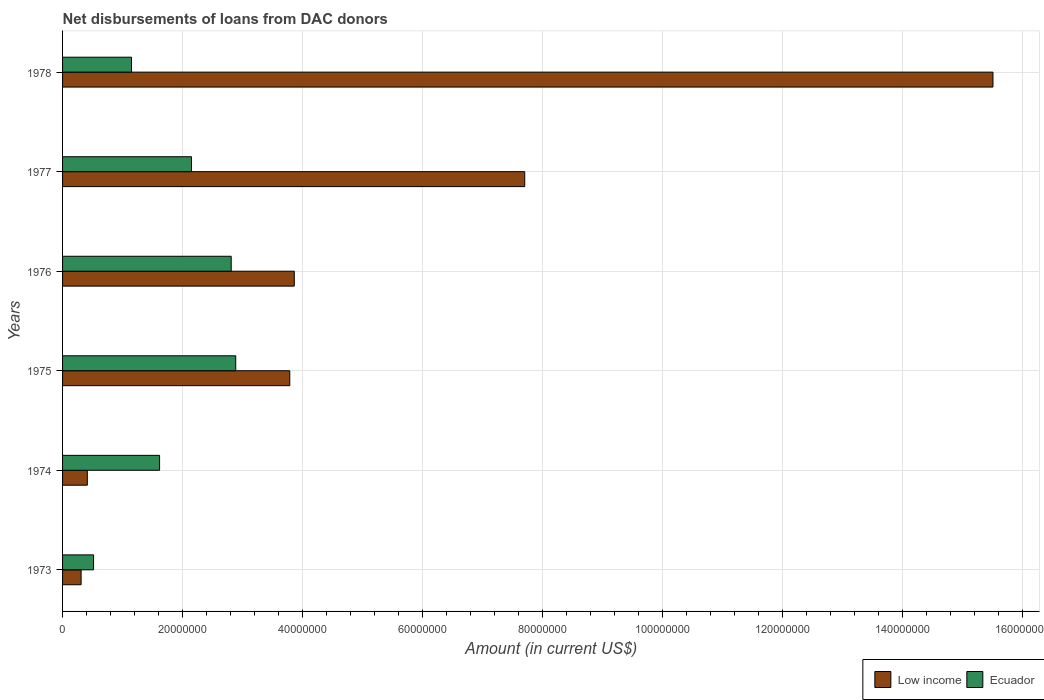How many groups of bars are there?
Your answer should be compact. 6. Are the number of bars per tick equal to the number of legend labels?
Offer a very short reply. Yes. Are the number of bars on each tick of the Y-axis equal?
Provide a short and direct response. Yes. How many bars are there on the 4th tick from the top?
Offer a terse response. 2. How many bars are there on the 2nd tick from the bottom?
Offer a terse response. 2. In how many cases, is the number of bars for a given year not equal to the number of legend labels?
Offer a terse response. 0. What is the amount of loans disbursed in Low income in 1973?
Your answer should be compact. 3.09e+06. Across all years, what is the maximum amount of loans disbursed in Ecuador?
Offer a very short reply. 2.89e+07. Across all years, what is the minimum amount of loans disbursed in Ecuador?
Make the answer very short. 5.17e+06. In which year was the amount of loans disbursed in Low income maximum?
Provide a short and direct response. 1978. What is the total amount of loans disbursed in Ecuador in the graph?
Ensure brevity in your answer.  1.11e+08. What is the difference between the amount of loans disbursed in Ecuador in 1975 and that in 1977?
Your answer should be compact. 7.37e+06. What is the difference between the amount of loans disbursed in Low income in 1978 and the amount of loans disbursed in Ecuador in 1976?
Ensure brevity in your answer.  1.27e+08. What is the average amount of loans disbursed in Ecuador per year?
Make the answer very short. 1.85e+07. In the year 1975, what is the difference between the amount of loans disbursed in Low income and amount of loans disbursed in Ecuador?
Your answer should be compact. 9.01e+06. In how many years, is the amount of loans disbursed in Ecuador greater than 12000000 US$?
Ensure brevity in your answer.  4. What is the ratio of the amount of loans disbursed in Ecuador in 1973 to that in 1975?
Offer a very short reply. 0.18. Is the difference between the amount of loans disbursed in Low income in 1973 and 1977 greater than the difference between the amount of loans disbursed in Ecuador in 1973 and 1977?
Offer a very short reply. No. What is the difference between the highest and the second highest amount of loans disbursed in Low income?
Your response must be concise. 7.80e+07. What is the difference between the highest and the lowest amount of loans disbursed in Ecuador?
Provide a short and direct response. 2.37e+07. In how many years, is the amount of loans disbursed in Ecuador greater than the average amount of loans disbursed in Ecuador taken over all years?
Provide a succinct answer. 3. What does the 1st bar from the top in 1975 represents?
Ensure brevity in your answer.  Ecuador. What does the 2nd bar from the bottom in 1976 represents?
Your answer should be compact. Ecuador. How many bars are there?
Your response must be concise. 12. How many years are there in the graph?
Make the answer very short. 6. Are the values on the major ticks of X-axis written in scientific E-notation?
Your answer should be compact. No. Does the graph contain any zero values?
Your answer should be very brief. No. Does the graph contain grids?
Offer a very short reply. Yes. What is the title of the graph?
Provide a succinct answer. Net disbursements of loans from DAC donors. Does "Rwanda" appear as one of the legend labels in the graph?
Make the answer very short. No. What is the label or title of the Y-axis?
Make the answer very short. Years. What is the Amount (in current US$) in Low income in 1973?
Give a very brief answer. 3.09e+06. What is the Amount (in current US$) in Ecuador in 1973?
Offer a very short reply. 5.17e+06. What is the Amount (in current US$) in Low income in 1974?
Your answer should be compact. 4.13e+06. What is the Amount (in current US$) of Ecuador in 1974?
Make the answer very short. 1.62e+07. What is the Amount (in current US$) of Low income in 1975?
Ensure brevity in your answer.  3.79e+07. What is the Amount (in current US$) in Ecuador in 1975?
Ensure brevity in your answer.  2.89e+07. What is the Amount (in current US$) in Low income in 1976?
Your answer should be compact. 3.86e+07. What is the Amount (in current US$) of Ecuador in 1976?
Provide a succinct answer. 2.81e+07. What is the Amount (in current US$) of Low income in 1977?
Offer a terse response. 7.70e+07. What is the Amount (in current US$) in Ecuador in 1977?
Provide a short and direct response. 2.15e+07. What is the Amount (in current US$) in Low income in 1978?
Give a very brief answer. 1.55e+08. What is the Amount (in current US$) of Ecuador in 1978?
Offer a terse response. 1.15e+07. Across all years, what is the maximum Amount (in current US$) of Low income?
Offer a terse response. 1.55e+08. Across all years, what is the maximum Amount (in current US$) of Ecuador?
Give a very brief answer. 2.89e+07. Across all years, what is the minimum Amount (in current US$) of Low income?
Your answer should be compact. 3.09e+06. Across all years, what is the minimum Amount (in current US$) in Ecuador?
Make the answer very short. 5.17e+06. What is the total Amount (in current US$) in Low income in the graph?
Make the answer very short. 3.16e+08. What is the total Amount (in current US$) of Ecuador in the graph?
Offer a terse response. 1.11e+08. What is the difference between the Amount (in current US$) of Low income in 1973 and that in 1974?
Keep it short and to the point. -1.04e+06. What is the difference between the Amount (in current US$) in Ecuador in 1973 and that in 1974?
Make the answer very short. -1.10e+07. What is the difference between the Amount (in current US$) of Low income in 1973 and that in 1975?
Make the answer very short. -3.48e+07. What is the difference between the Amount (in current US$) of Ecuador in 1973 and that in 1975?
Your answer should be compact. -2.37e+07. What is the difference between the Amount (in current US$) of Low income in 1973 and that in 1976?
Ensure brevity in your answer.  -3.55e+07. What is the difference between the Amount (in current US$) in Ecuador in 1973 and that in 1976?
Your response must be concise. -2.29e+07. What is the difference between the Amount (in current US$) in Low income in 1973 and that in 1977?
Give a very brief answer. -7.39e+07. What is the difference between the Amount (in current US$) in Ecuador in 1973 and that in 1977?
Give a very brief answer. -1.63e+07. What is the difference between the Amount (in current US$) of Low income in 1973 and that in 1978?
Make the answer very short. -1.52e+08. What is the difference between the Amount (in current US$) in Ecuador in 1973 and that in 1978?
Offer a very short reply. -6.32e+06. What is the difference between the Amount (in current US$) in Low income in 1974 and that in 1975?
Your response must be concise. -3.37e+07. What is the difference between the Amount (in current US$) in Ecuador in 1974 and that in 1975?
Your answer should be compact. -1.27e+07. What is the difference between the Amount (in current US$) in Low income in 1974 and that in 1976?
Provide a short and direct response. -3.45e+07. What is the difference between the Amount (in current US$) of Ecuador in 1974 and that in 1976?
Your answer should be compact. -1.19e+07. What is the difference between the Amount (in current US$) of Low income in 1974 and that in 1977?
Ensure brevity in your answer.  -7.29e+07. What is the difference between the Amount (in current US$) in Ecuador in 1974 and that in 1977?
Make the answer very short. -5.32e+06. What is the difference between the Amount (in current US$) in Low income in 1974 and that in 1978?
Give a very brief answer. -1.51e+08. What is the difference between the Amount (in current US$) of Ecuador in 1974 and that in 1978?
Provide a succinct answer. 4.68e+06. What is the difference between the Amount (in current US$) of Low income in 1975 and that in 1976?
Your answer should be compact. -7.53e+05. What is the difference between the Amount (in current US$) of Ecuador in 1975 and that in 1976?
Offer a very short reply. 7.55e+05. What is the difference between the Amount (in current US$) in Low income in 1975 and that in 1977?
Offer a very short reply. -3.92e+07. What is the difference between the Amount (in current US$) of Ecuador in 1975 and that in 1977?
Keep it short and to the point. 7.37e+06. What is the difference between the Amount (in current US$) in Low income in 1975 and that in 1978?
Give a very brief answer. -1.17e+08. What is the difference between the Amount (in current US$) in Ecuador in 1975 and that in 1978?
Offer a terse response. 1.74e+07. What is the difference between the Amount (in current US$) in Low income in 1976 and that in 1977?
Your answer should be very brief. -3.84e+07. What is the difference between the Amount (in current US$) in Ecuador in 1976 and that in 1977?
Offer a very short reply. 6.61e+06. What is the difference between the Amount (in current US$) in Low income in 1976 and that in 1978?
Make the answer very short. -1.16e+08. What is the difference between the Amount (in current US$) of Ecuador in 1976 and that in 1978?
Your response must be concise. 1.66e+07. What is the difference between the Amount (in current US$) in Low income in 1977 and that in 1978?
Offer a very short reply. -7.80e+07. What is the difference between the Amount (in current US$) of Ecuador in 1977 and that in 1978?
Provide a short and direct response. 1.00e+07. What is the difference between the Amount (in current US$) of Low income in 1973 and the Amount (in current US$) of Ecuador in 1974?
Offer a terse response. -1.31e+07. What is the difference between the Amount (in current US$) in Low income in 1973 and the Amount (in current US$) in Ecuador in 1975?
Your answer should be very brief. -2.58e+07. What is the difference between the Amount (in current US$) in Low income in 1973 and the Amount (in current US$) in Ecuador in 1976?
Give a very brief answer. -2.50e+07. What is the difference between the Amount (in current US$) in Low income in 1973 and the Amount (in current US$) in Ecuador in 1977?
Ensure brevity in your answer.  -1.84e+07. What is the difference between the Amount (in current US$) in Low income in 1973 and the Amount (in current US$) in Ecuador in 1978?
Ensure brevity in your answer.  -8.40e+06. What is the difference between the Amount (in current US$) of Low income in 1974 and the Amount (in current US$) of Ecuador in 1975?
Keep it short and to the point. -2.47e+07. What is the difference between the Amount (in current US$) of Low income in 1974 and the Amount (in current US$) of Ecuador in 1976?
Ensure brevity in your answer.  -2.40e+07. What is the difference between the Amount (in current US$) of Low income in 1974 and the Amount (in current US$) of Ecuador in 1977?
Your response must be concise. -1.74e+07. What is the difference between the Amount (in current US$) in Low income in 1974 and the Amount (in current US$) in Ecuador in 1978?
Give a very brief answer. -7.36e+06. What is the difference between the Amount (in current US$) of Low income in 1975 and the Amount (in current US$) of Ecuador in 1976?
Your response must be concise. 9.76e+06. What is the difference between the Amount (in current US$) of Low income in 1975 and the Amount (in current US$) of Ecuador in 1977?
Give a very brief answer. 1.64e+07. What is the difference between the Amount (in current US$) in Low income in 1975 and the Amount (in current US$) in Ecuador in 1978?
Make the answer very short. 2.64e+07. What is the difference between the Amount (in current US$) in Low income in 1976 and the Amount (in current US$) in Ecuador in 1977?
Your response must be concise. 1.71e+07. What is the difference between the Amount (in current US$) of Low income in 1976 and the Amount (in current US$) of Ecuador in 1978?
Ensure brevity in your answer.  2.71e+07. What is the difference between the Amount (in current US$) of Low income in 1977 and the Amount (in current US$) of Ecuador in 1978?
Keep it short and to the point. 6.55e+07. What is the average Amount (in current US$) in Low income per year?
Give a very brief answer. 5.26e+07. What is the average Amount (in current US$) of Ecuador per year?
Your response must be concise. 1.85e+07. In the year 1973, what is the difference between the Amount (in current US$) in Low income and Amount (in current US$) in Ecuador?
Keep it short and to the point. -2.08e+06. In the year 1974, what is the difference between the Amount (in current US$) of Low income and Amount (in current US$) of Ecuador?
Ensure brevity in your answer.  -1.20e+07. In the year 1975, what is the difference between the Amount (in current US$) of Low income and Amount (in current US$) of Ecuador?
Provide a short and direct response. 9.01e+06. In the year 1976, what is the difference between the Amount (in current US$) of Low income and Amount (in current US$) of Ecuador?
Give a very brief answer. 1.05e+07. In the year 1977, what is the difference between the Amount (in current US$) in Low income and Amount (in current US$) in Ecuador?
Provide a short and direct response. 5.55e+07. In the year 1978, what is the difference between the Amount (in current US$) of Low income and Amount (in current US$) of Ecuador?
Ensure brevity in your answer.  1.44e+08. What is the ratio of the Amount (in current US$) of Low income in 1973 to that in 1974?
Offer a very short reply. 0.75. What is the ratio of the Amount (in current US$) of Ecuador in 1973 to that in 1974?
Provide a short and direct response. 0.32. What is the ratio of the Amount (in current US$) in Low income in 1973 to that in 1975?
Offer a very short reply. 0.08. What is the ratio of the Amount (in current US$) of Ecuador in 1973 to that in 1975?
Your answer should be compact. 0.18. What is the ratio of the Amount (in current US$) in Ecuador in 1973 to that in 1976?
Provide a succinct answer. 0.18. What is the ratio of the Amount (in current US$) of Low income in 1973 to that in 1977?
Offer a terse response. 0.04. What is the ratio of the Amount (in current US$) of Ecuador in 1973 to that in 1977?
Your response must be concise. 0.24. What is the ratio of the Amount (in current US$) in Low income in 1973 to that in 1978?
Give a very brief answer. 0.02. What is the ratio of the Amount (in current US$) in Ecuador in 1973 to that in 1978?
Your answer should be very brief. 0.45. What is the ratio of the Amount (in current US$) of Low income in 1974 to that in 1975?
Provide a succinct answer. 0.11. What is the ratio of the Amount (in current US$) in Ecuador in 1974 to that in 1975?
Your response must be concise. 0.56. What is the ratio of the Amount (in current US$) in Low income in 1974 to that in 1976?
Your answer should be very brief. 0.11. What is the ratio of the Amount (in current US$) in Ecuador in 1974 to that in 1976?
Your answer should be very brief. 0.58. What is the ratio of the Amount (in current US$) in Low income in 1974 to that in 1977?
Your answer should be compact. 0.05. What is the ratio of the Amount (in current US$) of Ecuador in 1974 to that in 1977?
Provide a short and direct response. 0.75. What is the ratio of the Amount (in current US$) of Low income in 1974 to that in 1978?
Provide a short and direct response. 0.03. What is the ratio of the Amount (in current US$) of Ecuador in 1974 to that in 1978?
Your response must be concise. 1.41. What is the ratio of the Amount (in current US$) in Low income in 1975 to that in 1976?
Keep it short and to the point. 0.98. What is the ratio of the Amount (in current US$) in Ecuador in 1975 to that in 1976?
Keep it short and to the point. 1.03. What is the ratio of the Amount (in current US$) of Low income in 1975 to that in 1977?
Offer a very short reply. 0.49. What is the ratio of the Amount (in current US$) of Ecuador in 1975 to that in 1977?
Your answer should be compact. 1.34. What is the ratio of the Amount (in current US$) of Low income in 1975 to that in 1978?
Offer a very short reply. 0.24. What is the ratio of the Amount (in current US$) of Ecuador in 1975 to that in 1978?
Your answer should be very brief. 2.51. What is the ratio of the Amount (in current US$) of Low income in 1976 to that in 1977?
Provide a short and direct response. 0.5. What is the ratio of the Amount (in current US$) in Ecuador in 1976 to that in 1977?
Provide a succinct answer. 1.31. What is the ratio of the Amount (in current US$) in Low income in 1976 to that in 1978?
Your response must be concise. 0.25. What is the ratio of the Amount (in current US$) in Ecuador in 1976 to that in 1978?
Provide a succinct answer. 2.45. What is the ratio of the Amount (in current US$) in Low income in 1977 to that in 1978?
Your response must be concise. 0.5. What is the ratio of the Amount (in current US$) in Ecuador in 1977 to that in 1978?
Provide a short and direct response. 1.87. What is the difference between the highest and the second highest Amount (in current US$) of Low income?
Offer a very short reply. 7.80e+07. What is the difference between the highest and the second highest Amount (in current US$) in Ecuador?
Your response must be concise. 7.55e+05. What is the difference between the highest and the lowest Amount (in current US$) in Low income?
Your answer should be very brief. 1.52e+08. What is the difference between the highest and the lowest Amount (in current US$) in Ecuador?
Your response must be concise. 2.37e+07. 